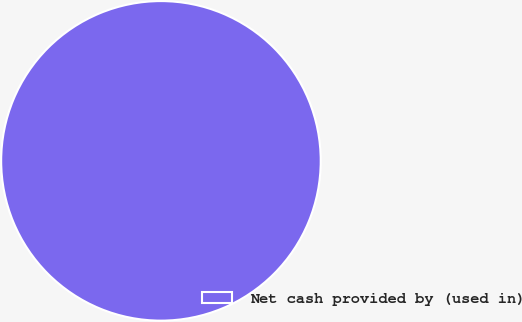<chart> <loc_0><loc_0><loc_500><loc_500><pie_chart><fcel>Net cash provided by (used in)<nl><fcel>100.0%<nl></chart> 